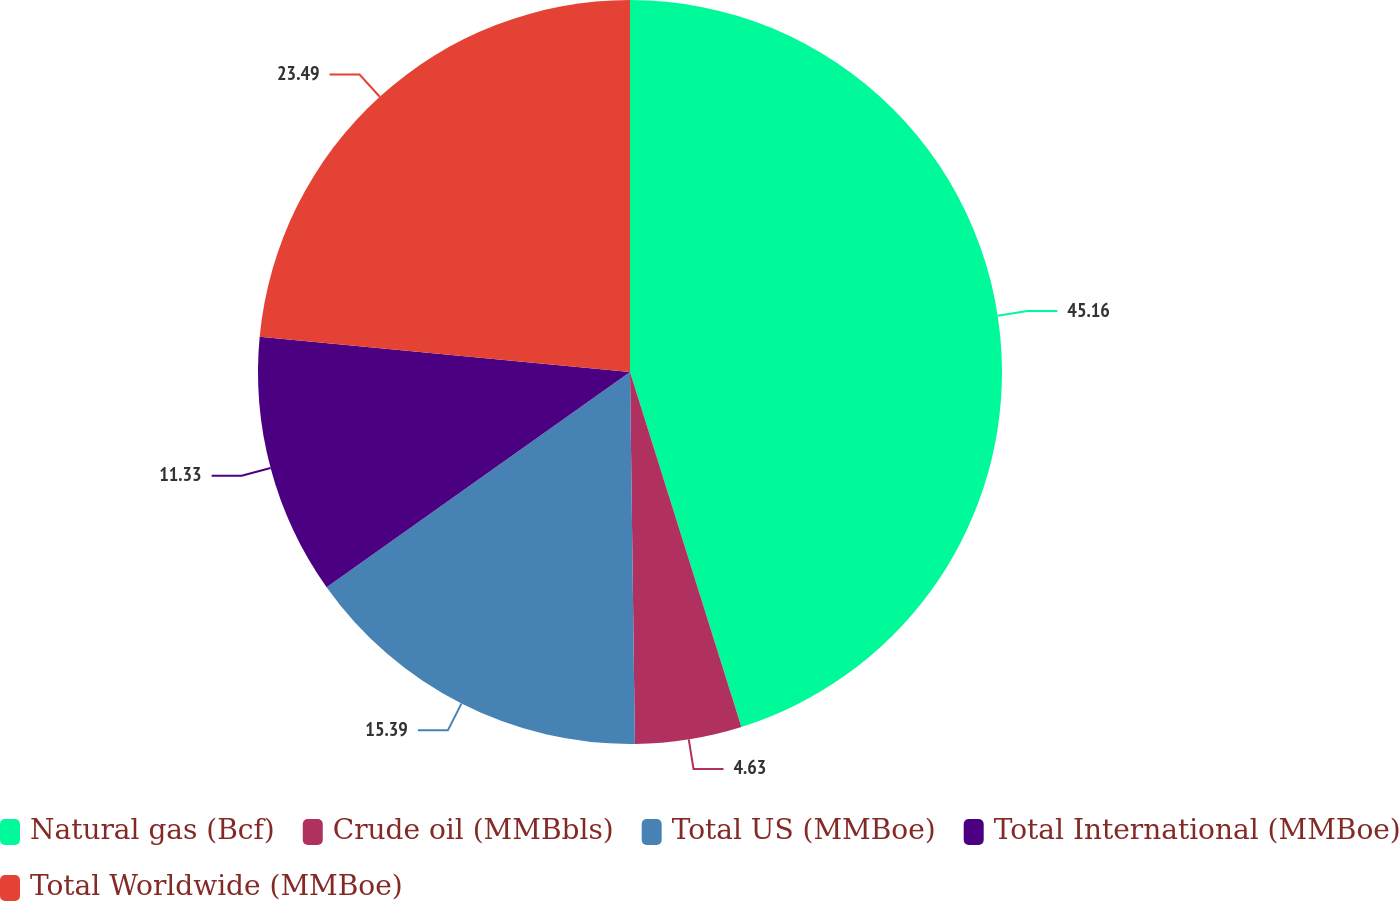Convert chart to OTSL. <chart><loc_0><loc_0><loc_500><loc_500><pie_chart><fcel>Natural gas (Bcf)<fcel>Crude oil (MMBbls)<fcel>Total US (MMBoe)<fcel>Total International (MMBoe)<fcel>Total Worldwide (MMBoe)<nl><fcel>45.16%<fcel>4.63%<fcel>15.39%<fcel>11.33%<fcel>23.49%<nl></chart> 